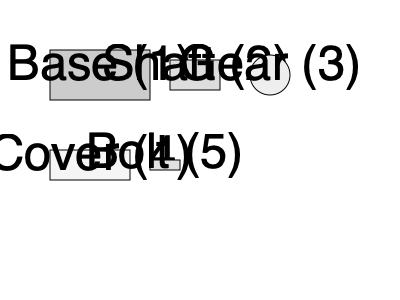Based on the exploded view of a mechanical assembly shown above, what is the correct sequence for assembling these components? To determine the correct assembly sequence, we need to analyze the relationship between the components:

1. The base (1) is the foundation of the assembly, so it must be placed first.

2. The shaft (2) appears to be designed to fit into the base, so it should be inserted next.

3. The gear (3) is likely to be mounted on the shaft, so it would be placed after the shaft is in position.

4. The cover (4) seems to be designed to enclose the assembly, protecting the internal components. It would be placed after the gear is mounted.

5. The bolt (5) is typically used to secure components together. In this case, it's likely used to fasten the cover to the base, so it would be the last component to be installed.

Therefore, the logical assembly sequence would be: Base (1) → Shaft (2) → Gear (3) → Cover (4) → Bolt (5).
Answer: 1-2-3-4-5 